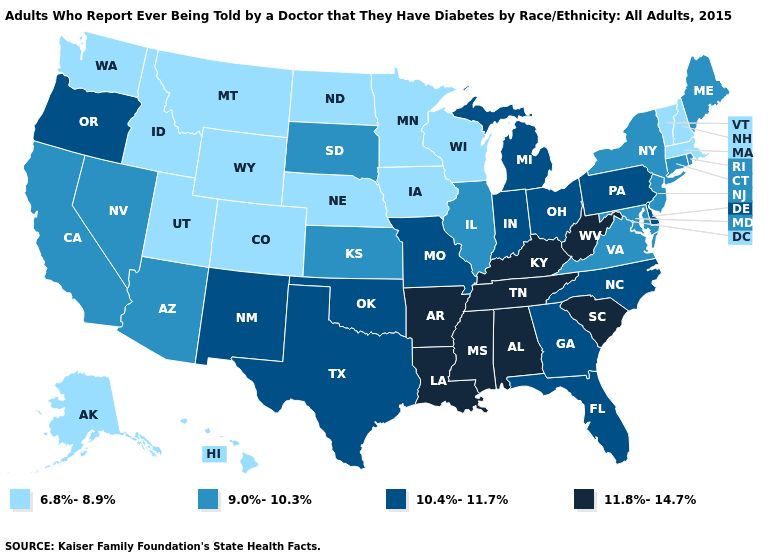What is the lowest value in the West?
Quick response, please. 6.8%-8.9%. Which states have the highest value in the USA?
Be succinct. Alabama, Arkansas, Kentucky, Louisiana, Mississippi, South Carolina, Tennessee, West Virginia. Which states have the lowest value in the West?
Short answer required. Alaska, Colorado, Hawaii, Idaho, Montana, Utah, Washington, Wyoming. What is the highest value in states that border Virginia?
Be succinct. 11.8%-14.7%. What is the highest value in the West ?
Give a very brief answer. 10.4%-11.7%. Which states have the lowest value in the USA?
Write a very short answer. Alaska, Colorado, Hawaii, Idaho, Iowa, Massachusetts, Minnesota, Montana, Nebraska, New Hampshire, North Dakota, Utah, Vermont, Washington, Wisconsin, Wyoming. Does Connecticut have the highest value in the USA?
Answer briefly. No. Is the legend a continuous bar?
Be succinct. No. Name the states that have a value in the range 10.4%-11.7%?
Concise answer only. Delaware, Florida, Georgia, Indiana, Michigan, Missouri, New Mexico, North Carolina, Ohio, Oklahoma, Oregon, Pennsylvania, Texas. Name the states that have a value in the range 10.4%-11.7%?
Give a very brief answer. Delaware, Florida, Georgia, Indiana, Michigan, Missouri, New Mexico, North Carolina, Ohio, Oklahoma, Oregon, Pennsylvania, Texas. What is the lowest value in the USA?
Answer briefly. 6.8%-8.9%. Which states have the lowest value in the South?
Quick response, please. Maryland, Virginia. Does Ohio have the highest value in the MidWest?
Answer briefly. Yes. What is the value of New Hampshire?
Give a very brief answer. 6.8%-8.9%. Name the states that have a value in the range 6.8%-8.9%?
Keep it brief. Alaska, Colorado, Hawaii, Idaho, Iowa, Massachusetts, Minnesota, Montana, Nebraska, New Hampshire, North Dakota, Utah, Vermont, Washington, Wisconsin, Wyoming. 